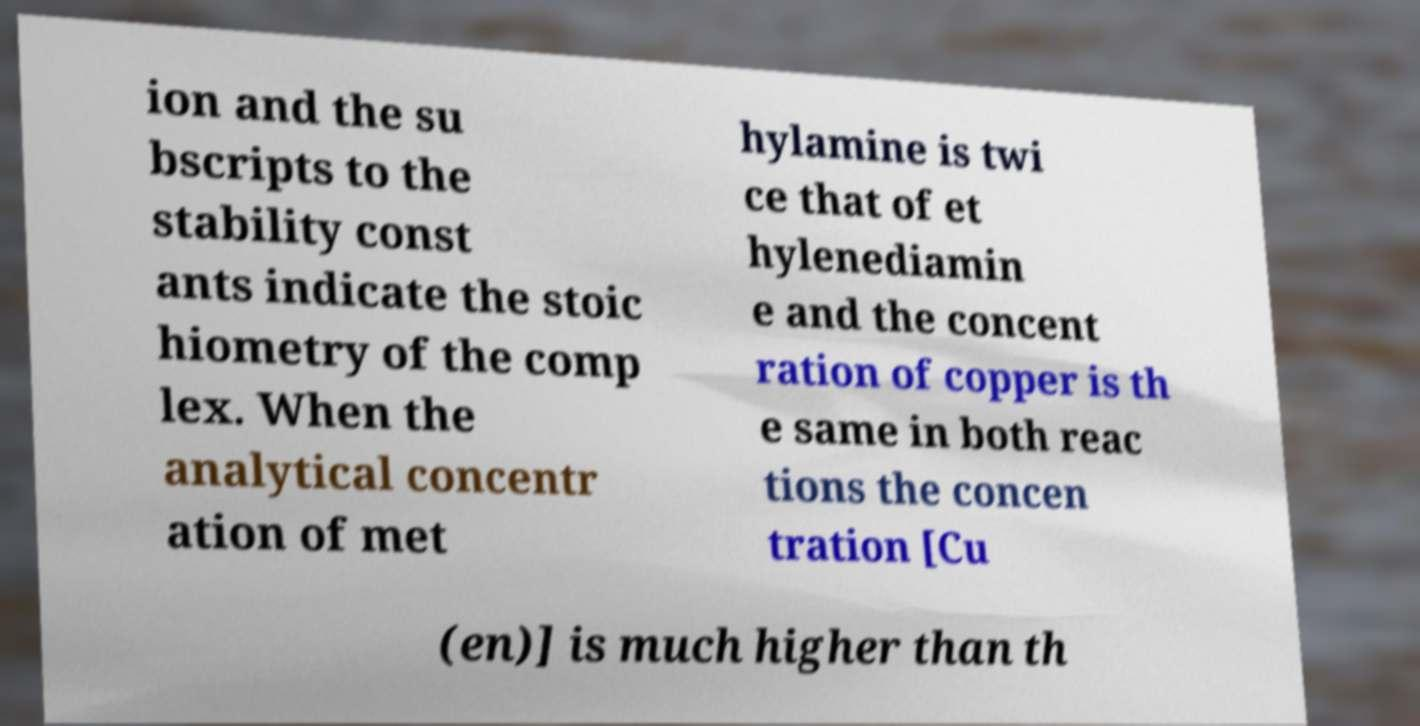Can you accurately transcribe the text from the provided image for me? ion and the su bscripts to the stability const ants indicate the stoic hiometry of the comp lex. When the analytical concentr ation of met hylamine is twi ce that of et hylenediamin e and the concent ration of copper is th e same in both reac tions the concen tration [Cu (en)] is much higher than th 